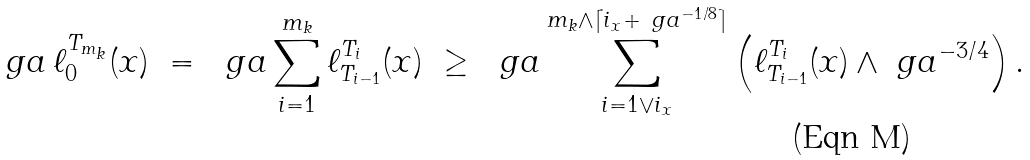<formula> <loc_0><loc_0><loc_500><loc_500>\ g a \, \ell _ { 0 } ^ { T _ { m _ { k } } } ( x ) \ = \ \ g a \sum _ { i = 1 } ^ { m _ { k } } \ell _ { T _ { i - 1 } } ^ { T _ { i } } ( x ) \ \geq \ \ g a \sum _ { i = 1 \vee i _ { x } } ^ { m _ { k } \wedge \lceil i _ { x } + \ g a ^ { - 1 / 8 } \rceil } \left ( \ell _ { T _ { i - 1 } } ^ { T _ { i } } ( x ) \wedge \ g a ^ { - 3 / 4 } \right ) .</formula> 